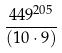Convert formula to latex. <formula><loc_0><loc_0><loc_500><loc_500>\frac { 4 4 9 ^ { 2 0 5 } } { ( 1 0 \cdot 9 ) }</formula> 